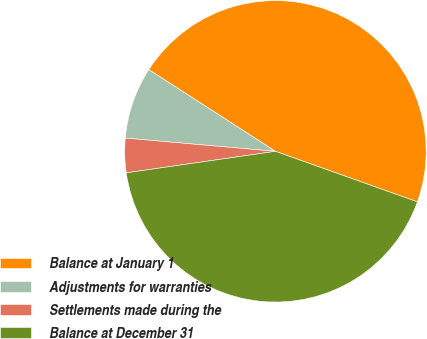Convert chart to OTSL. <chart><loc_0><loc_0><loc_500><loc_500><pie_chart><fcel>Balance at January 1<fcel>Adjustments for warranties<fcel>Settlements made during the<fcel>Balance at December 31<nl><fcel>46.32%<fcel>7.72%<fcel>3.68%<fcel>42.28%<nl></chart> 